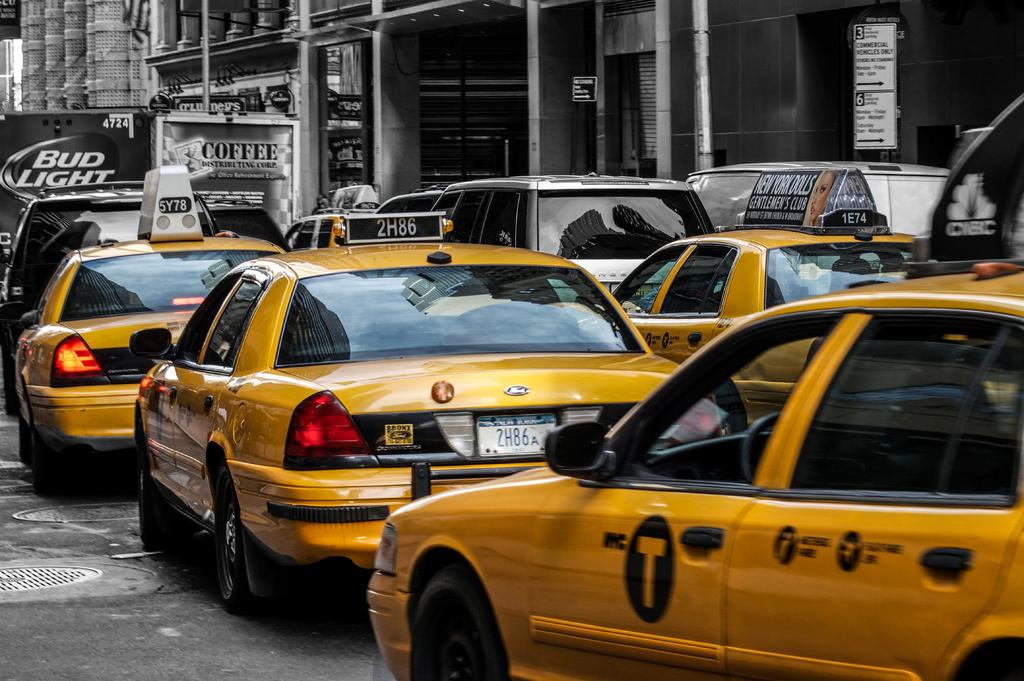What is on the license plate of the middle taxi?
Keep it short and to the point. 2h86a. 